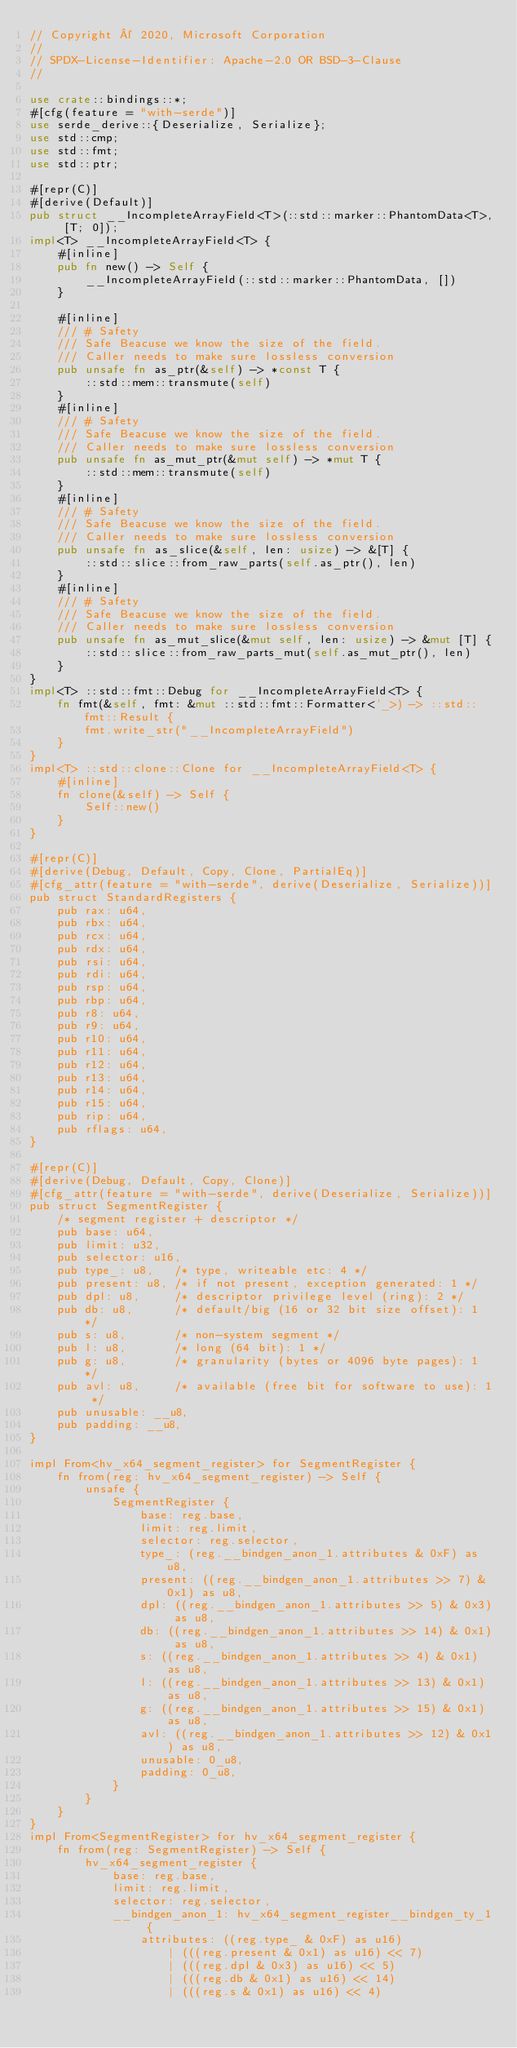<code> <loc_0><loc_0><loc_500><loc_500><_Rust_>// Copyright © 2020, Microsoft Corporation
//
// SPDX-License-Identifier: Apache-2.0 OR BSD-3-Clause
//

use crate::bindings::*;
#[cfg(feature = "with-serde")]
use serde_derive::{Deserialize, Serialize};
use std::cmp;
use std::fmt;
use std::ptr;

#[repr(C)]
#[derive(Default)]
pub struct __IncompleteArrayField<T>(::std::marker::PhantomData<T>, [T; 0]);
impl<T> __IncompleteArrayField<T> {
    #[inline]
    pub fn new() -> Self {
        __IncompleteArrayField(::std::marker::PhantomData, [])
    }

    #[inline]
    /// # Safety
    /// Safe Beacuse we know the size of the field.
    /// Caller needs to make sure lossless conversion
    pub unsafe fn as_ptr(&self) -> *const T {
        ::std::mem::transmute(self)
    }
    #[inline]
    /// # Safety
    /// Safe Beacuse we know the size of the field.
    /// Caller needs to make sure lossless conversion
    pub unsafe fn as_mut_ptr(&mut self) -> *mut T {
        ::std::mem::transmute(self)
    }
    #[inline]
    /// # Safety
    /// Safe Beacuse we know the size of the field.
    /// Caller needs to make sure lossless conversion
    pub unsafe fn as_slice(&self, len: usize) -> &[T] {
        ::std::slice::from_raw_parts(self.as_ptr(), len)
    }
    #[inline]
    /// # Safety
    /// Safe Beacuse we know the size of the field.
    /// Caller needs to make sure lossless conversion
    pub unsafe fn as_mut_slice(&mut self, len: usize) -> &mut [T] {
        ::std::slice::from_raw_parts_mut(self.as_mut_ptr(), len)
    }
}
impl<T> ::std::fmt::Debug for __IncompleteArrayField<T> {
    fn fmt(&self, fmt: &mut ::std::fmt::Formatter<'_>) -> ::std::fmt::Result {
        fmt.write_str("__IncompleteArrayField")
    }
}
impl<T> ::std::clone::Clone for __IncompleteArrayField<T> {
    #[inline]
    fn clone(&self) -> Self {
        Self::new()
    }
}

#[repr(C)]
#[derive(Debug, Default, Copy, Clone, PartialEq)]
#[cfg_attr(feature = "with-serde", derive(Deserialize, Serialize))]
pub struct StandardRegisters {
    pub rax: u64,
    pub rbx: u64,
    pub rcx: u64,
    pub rdx: u64,
    pub rsi: u64,
    pub rdi: u64,
    pub rsp: u64,
    pub rbp: u64,
    pub r8: u64,
    pub r9: u64,
    pub r10: u64,
    pub r11: u64,
    pub r12: u64,
    pub r13: u64,
    pub r14: u64,
    pub r15: u64,
    pub rip: u64,
    pub rflags: u64,
}

#[repr(C)]
#[derive(Debug, Default, Copy, Clone)]
#[cfg_attr(feature = "with-serde", derive(Deserialize, Serialize))]
pub struct SegmentRegister {
    /* segment register + descriptor */
    pub base: u64,
    pub limit: u32,
    pub selector: u16,
    pub type_: u8,   /* type, writeable etc: 4 */
    pub present: u8, /* if not present, exception generated: 1 */
    pub dpl: u8,     /* descriptor privilege level (ring): 2 */
    pub db: u8,      /* default/big (16 or 32 bit size offset): 1 */
    pub s: u8,       /* non-system segment */
    pub l: u8,       /* long (64 bit): 1 */
    pub g: u8,       /* granularity (bytes or 4096 byte pages): 1 */
    pub avl: u8,     /* available (free bit for software to use): 1 */
    pub unusable: __u8,
    pub padding: __u8,
}

impl From<hv_x64_segment_register> for SegmentRegister {
    fn from(reg: hv_x64_segment_register) -> Self {
        unsafe {
            SegmentRegister {
                base: reg.base,
                limit: reg.limit,
                selector: reg.selector,
                type_: (reg.__bindgen_anon_1.attributes & 0xF) as u8,
                present: ((reg.__bindgen_anon_1.attributes >> 7) & 0x1) as u8,
                dpl: ((reg.__bindgen_anon_1.attributes >> 5) & 0x3) as u8,
                db: ((reg.__bindgen_anon_1.attributes >> 14) & 0x1) as u8,
                s: ((reg.__bindgen_anon_1.attributes >> 4) & 0x1) as u8,
                l: ((reg.__bindgen_anon_1.attributes >> 13) & 0x1) as u8,
                g: ((reg.__bindgen_anon_1.attributes >> 15) & 0x1) as u8,
                avl: ((reg.__bindgen_anon_1.attributes >> 12) & 0x1) as u8,
                unusable: 0_u8,
                padding: 0_u8,
            }
        }
    }
}
impl From<SegmentRegister> for hv_x64_segment_register {
    fn from(reg: SegmentRegister) -> Self {
        hv_x64_segment_register {
            base: reg.base,
            limit: reg.limit,
            selector: reg.selector,
            __bindgen_anon_1: hv_x64_segment_register__bindgen_ty_1 {
                attributes: ((reg.type_ & 0xF) as u16)
                    | (((reg.present & 0x1) as u16) << 7)
                    | (((reg.dpl & 0x3) as u16) << 5)
                    | (((reg.db & 0x1) as u16) << 14)
                    | (((reg.s & 0x1) as u16) << 4)</code> 